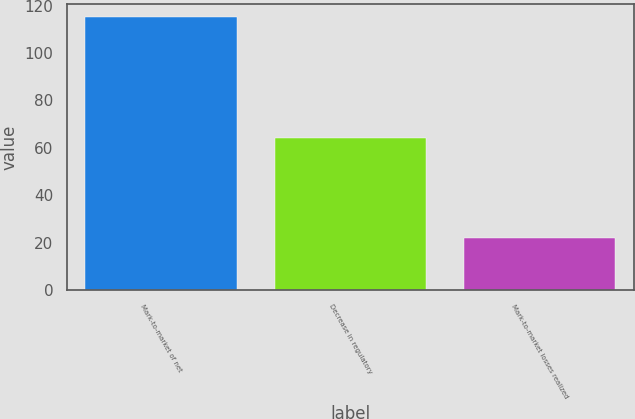<chart> <loc_0><loc_0><loc_500><loc_500><bar_chart><fcel>Mark-to-market of net<fcel>Decrease in regulatory<fcel>Mark-to-market losses realized<nl><fcel>115<fcel>64<fcel>22<nl></chart> 